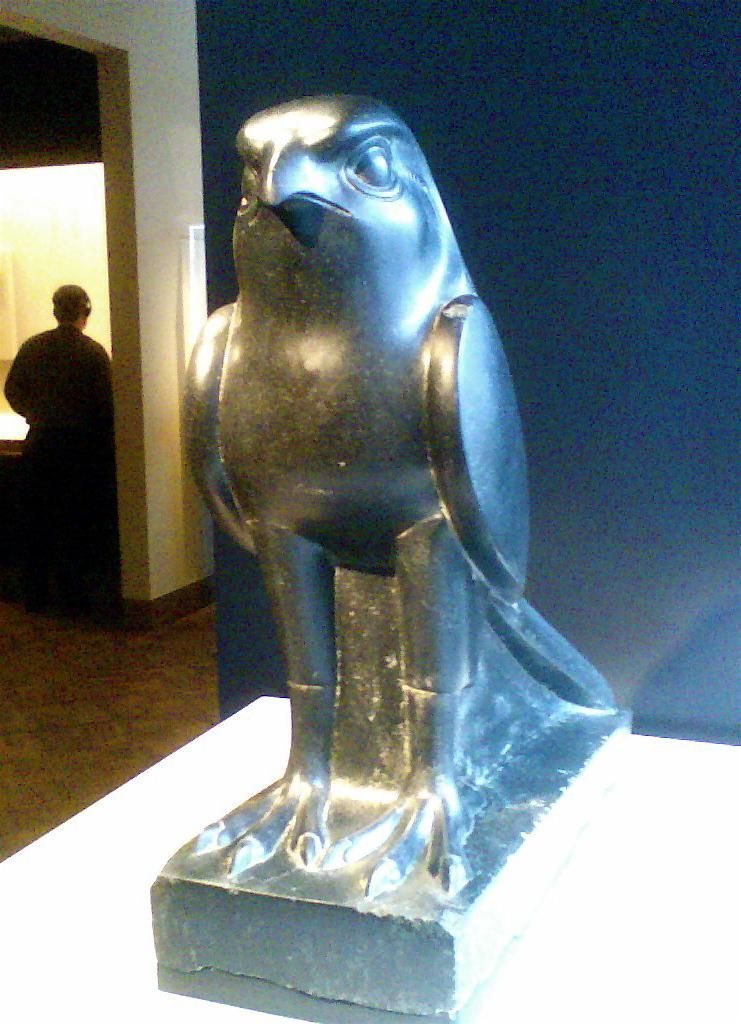What is the color of the statue in the image? The statue is black colored in the image. What is the statue depicting? The statue is of a bird. What is the color of the surface the statue is placed on? The surface is white colored. What can be seen in the background of the image? There is a wall, a person, and a light in the background of the image. What type of meal is being prepared by the cat in the image? There is no cat present in the image, and therefore no meal preparation can be observed. 